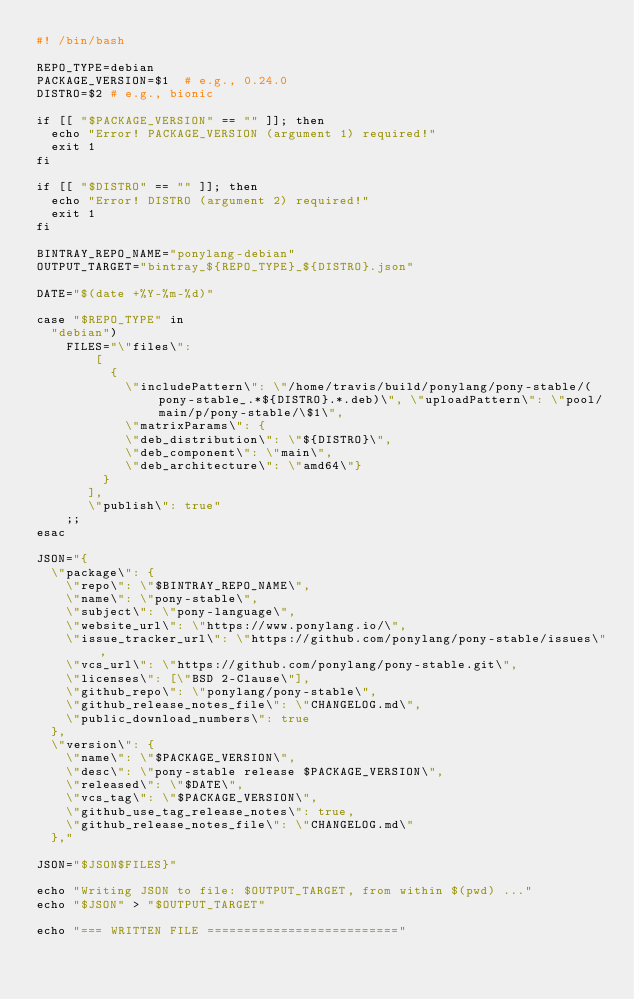<code> <loc_0><loc_0><loc_500><loc_500><_Bash_>#! /bin/bash

REPO_TYPE=debian
PACKAGE_VERSION=$1  # e.g., 0.24.0
DISTRO=$2 # e.g., bionic

if [[ "$PACKAGE_VERSION" == "" ]]; then
  echo "Error! PACKAGE_VERSION (argument 1) required!"
  exit 1
fi

if [[ "$DISTRO" == "" ]]; then
  echo "Error! DISTRO (argument 2) required!"
  exit 1
fi

BINTRAY_REPO_NAME="ponylang-debian"
OUTPUT_TARGET="bintray_${REPO_TYPE}_${DISTRO}.json"

DATE="$(date +%Y-%m-%d)"

case "$REPO_TYPE" in
  "debian")
    FILES="\"files\":
        [
          {
            \"includePattern\": \"/home/travis/build/ponylang/pony-stable/(pony-stable_.*${DISTRO}.*.deb)\", \"uploadPattern\": \"pool/main/p/pony-stable/\$1\",
            \"matrixParams\": {
            \"deb_distribution\": \"${DISTRO}\",
            \"deb_component\": \"main\",
            \"deb_architecture\": \"amd64\"}
         }
       ],
       \"publish\": true"
    ;;
esac

JSON="{
  \"package\": {
    \"repo\": \"$BINTRAY_REPO_NAME\",
    \"name\": \"pony-stable\",
    \"subject\": \"pony-language\",
    \"website_url\": \"https://www.ponylang.io/\",
    \"issue_tracker_url\": \"https://github.com/ponylang/pony-stable/issues\",
    \"vcs_url\": \"https://github.com/ponylang/pony-stable.git\",
    \"licenses\": [\"BSD 2-Clause\"],
    \"github_repo\": \"ponylang/pony-stable\",
    \"github_release_notes_file\": \"CHANGELOG.md\",
    \"public_download_numbers\": true
  },
  \"version\": {
    \"name\": \"$PACKAGE_VERSION\",
    \"desc\": \"pony-stable release $PACKAGE_VERSION\",
    \"released\": \"$DATE\",
    \"vcs_tag\": \"$PACKAGE_VERSION\",
    \"github_use_tag_release_notes\": true,
    \"github_release_notes_file\": \"CHANGELOG.md\"
  },"

JSON="$JSON$FILES}"

echo "Writing JSON to file: $OUTPUT_TARGET, from within $(pwd) ..."
echo "$JSON" > "$OUTPUT_TARGET"

echo "=== WRITTEN FILE =========================="</code> 